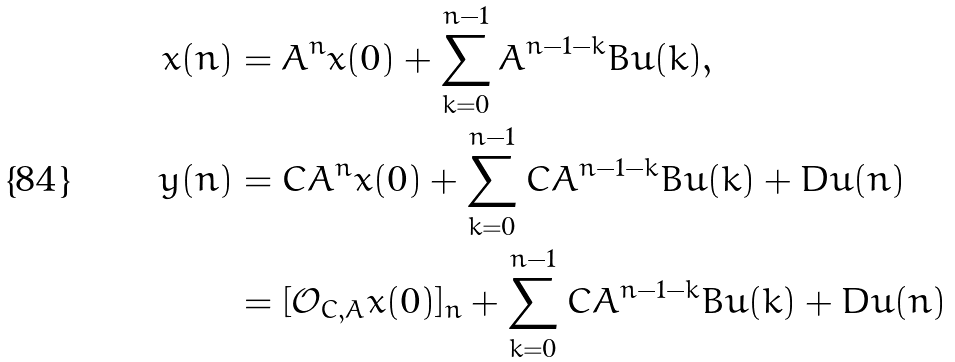Convert formula to latex. <formula><loc_0><loc_0><loc_500><loc_500>x ( n ) & = A ^ { n } x ( 0 ) + \sum _ { k = 0 } ^ { n - 1 } A ^ { n - 1 - k } B u ( k ) , \\ y ( n ) & = C A ^ { n } x ( 0 ) + \sum _ { k = 0 } ^ { n - 1 } C A ^ { n - 1 - k } B u ( k ) + D u ( n ) \\ & = [ { \mathcal { O } } _ { C , A } x ( 0 ) ] _ { n } + \sum _ { k = 0 } ^ { n - 1 } C A ^ { n - 1 - k } B u ( k ) + D u ( n )</formula> 